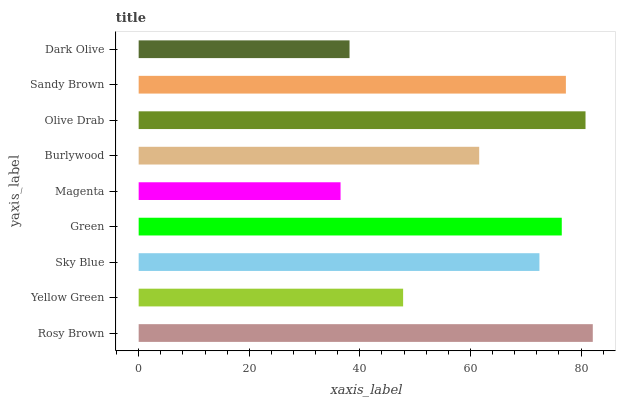Is Magenta the minimum?
Answer yes or no. Yes. Is Rosy Brown the maximum?
Answer yes or no. Yes. Is Yellow Green the minimum?
Answer yes or no. No. Is Yellow Green the maximum?
Answer yes or no. No. Is Rosy Brown greater than Yellow Green?
Answer yes or no. Yes. Is Yellow Green less than Rosy Brown?
Answer yes or no. Yes. Is Yellow Green greater than Rosy Brown?
Answer yes or no. No. Is Rosy Brown less than Yellow Green?
Answer yes or no. No. Is Sky Blue the high median?
Answer yes or no. Yes. Is Sky Blue the low median?
Answer yes or no. Yes. Is Dark Olive the high median?
Answer yes or no. No. Is Green the low median?
Answer yes or no. No. 